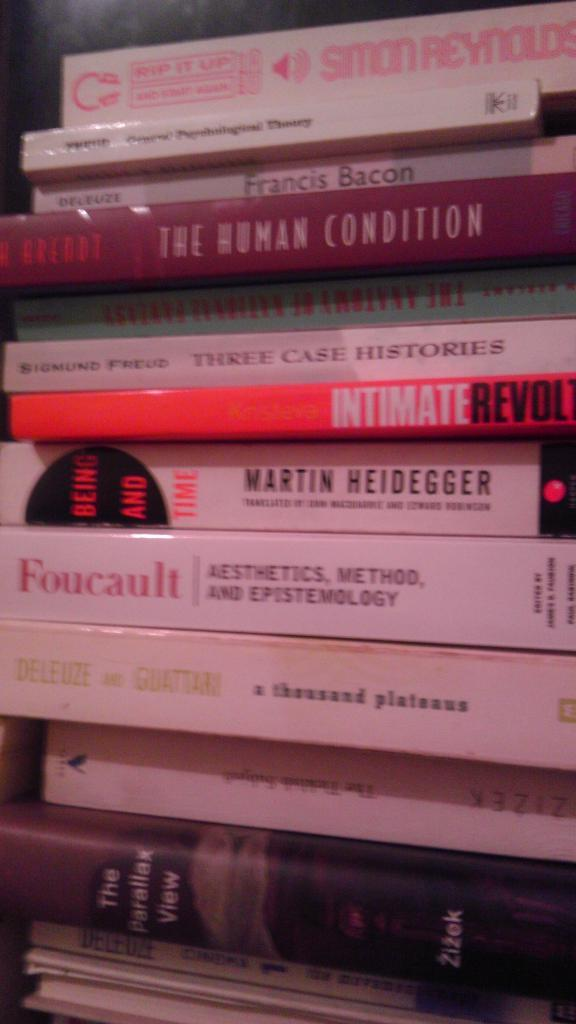<image>
Offer a succinct explanation of the picture presented. The fourth book down in the stack is titled, "The Human Condition." 